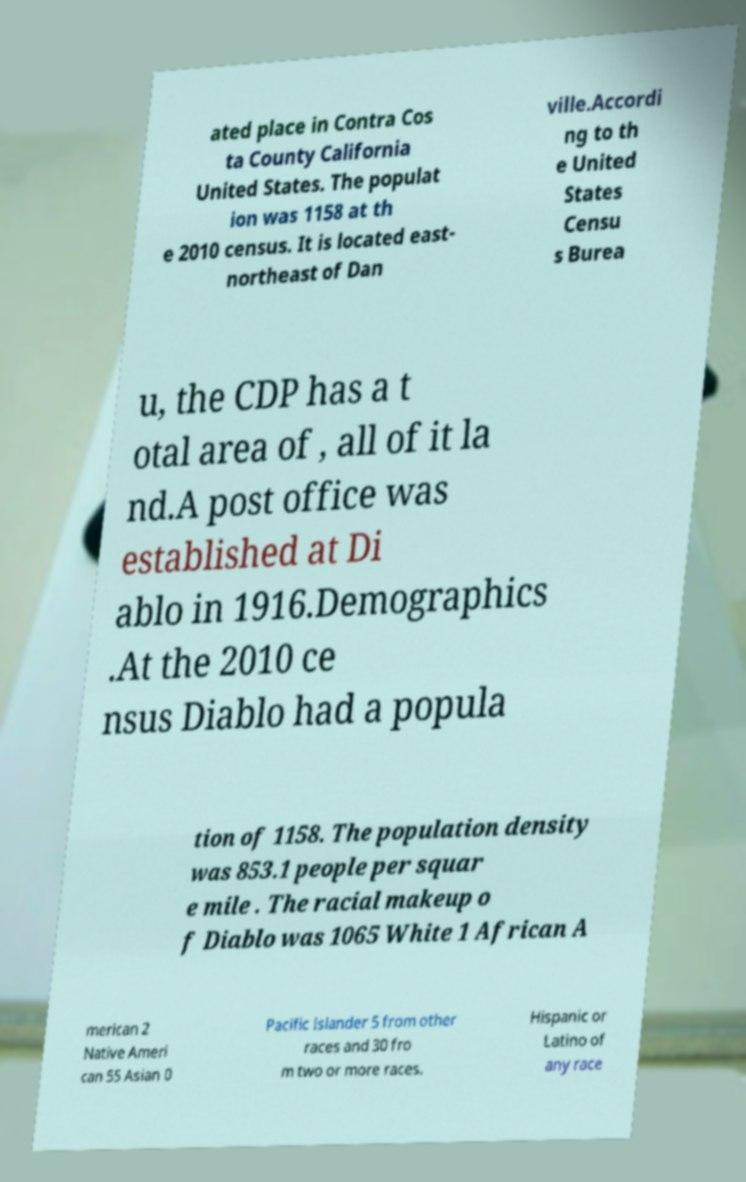What messages or text are displayed in this image? I need them in a readable, typed format. ated place in Contra Cos ta County California United States. The populat ion was 1158 at th e 2010 census. It is located east- northeast of Dan ville.Accordi ng to th e United States Censu s Burea u, the CDP has a t otal area of , all of it la nd.A post office was established at Di ablo in 1916.Demographics .At the 2010 ce nsus Diablo had a popula tion of 1158. The population density was 853.1 people per squar e mile . The racial makeup o f Diablo was 1065 White 1 African A merican 2 Native Ameri can 55 Asian 0 Pacific Islander 5 from other races and 30 fro m two or more races. Hispanic or Latino of any race 